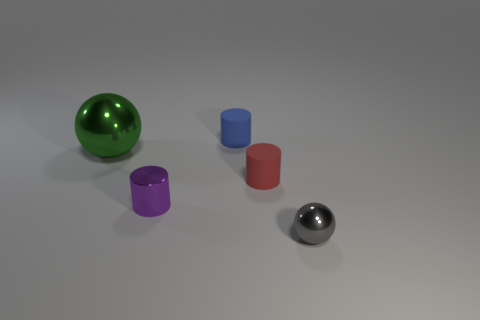Subtract all blue cylinders. How many cylinders are left? 2 Add 5 tiny purple cylinders. How many objects exist? 10 Subtract all green spheres. How many spheres are left? 1 Subtract all cylinders. How many objects are left? 2 Add 1 big green spheres. How many big green spheres are left? 2 Add 3 green rubber cylinders. How many green rubber cylinders exist? 3 Subtract 1 purple cylinders. How many objects are left? 4 Subtract all brown balls. Subtract all yellow cylinders. How many balls are left? 2 Subtract all red balls. How many red cylinders are left? 1 Subtract all large cyan metal blocks. Subtract all tiny gray things. How many objects are left? 4 